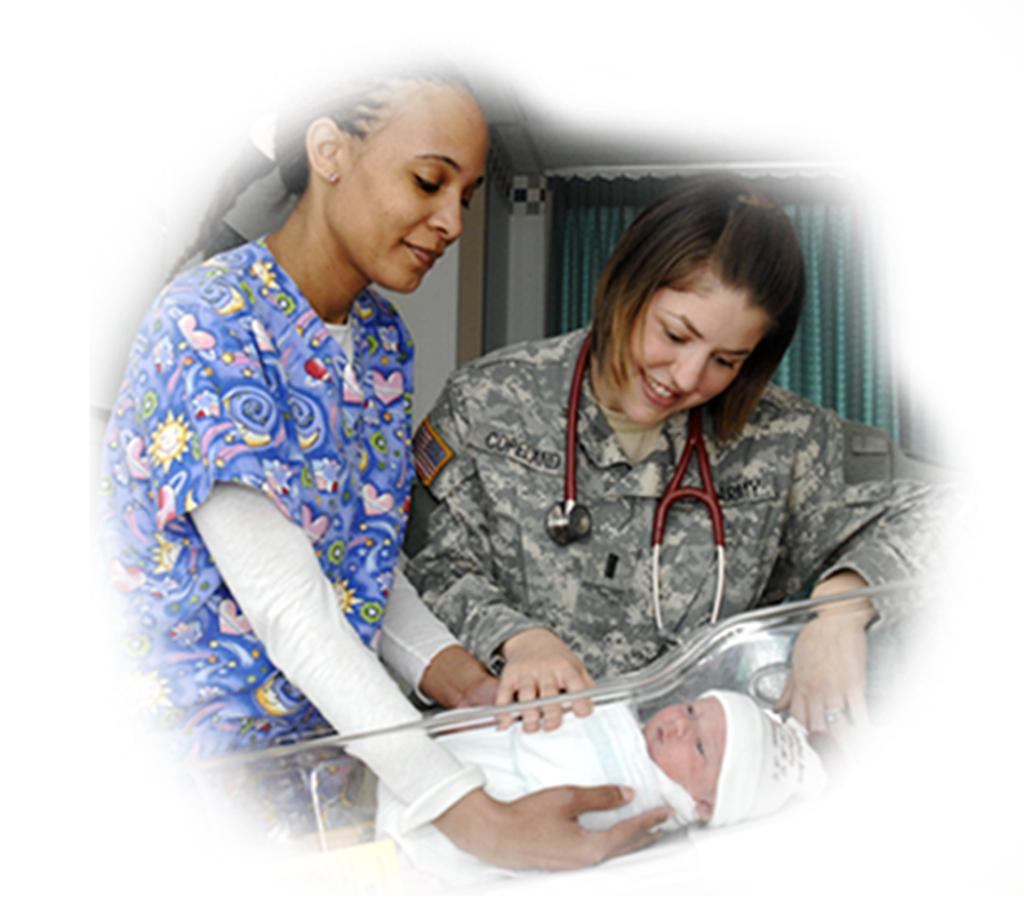How many women are in the image? There are two women in the image. What is the facial expression of the women? Both women are smiling. What is the woman on the left side of the image holding? The woman on the left side of the image is holding a baby. How is the baby contained in the image? The baby is in a glass. What can be seen in the background of the image? There is a wall and a curtain in the background of the image. What type of plastic is used to make the pump in the image? There is no pump present in the image, so it is not possible to determine the type of plastic used. 